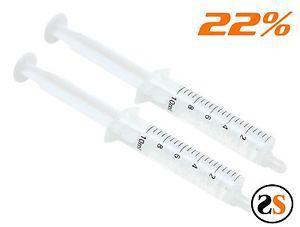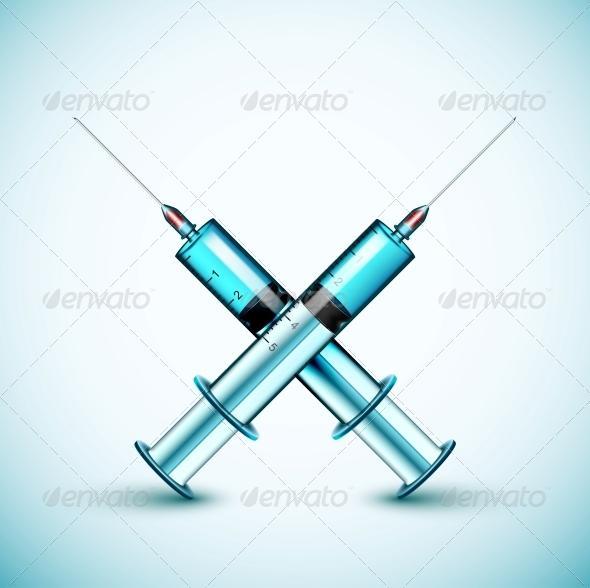The first image is the image on the left, the second image is the image on the right. Examine the images to the left and right. Is the description "An image features exactly one syringe with an exposed needle tip." accurate? Answer yes or no. No. The first image is the image on the left, the second image is the image on the right. For the images shown, is this caption "There are four or more syringes in total." true? Answer yes or no. Yes. 